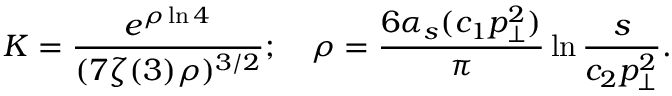Convert formula to latex. <formula><loc_0><loc_0><loc_500><loc_500>K = \frac { e ^ { \rho \ln 4 } } { ( 7 \zeta ( 3 ) \rho ) ^ { 3 / 2 } } ; \quad \rho = \frac { 6 \alpha _ { s } ( c _ { 1 } p _ { \bot } ^ { 2 } ) } { \pi } \ln { \frac { s } { c _ { 2 } p _ { \bot } ^ { 2 } } } .</formula> 